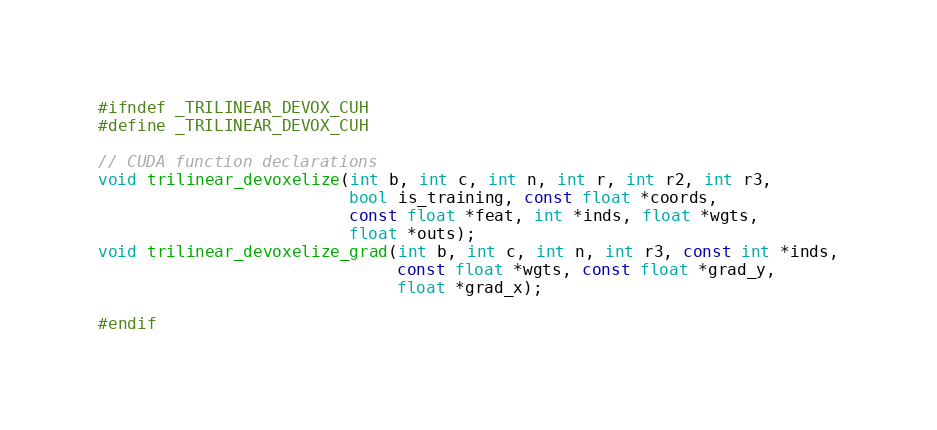<code> <loc_0><loc_0><loc_500><loc_500><_Cuda_>#ifndef _TRILINEAR_DEVOX_CUH
#define _TRILINEAR_DEVOX_CUH

// CUDA function declarations
void trilinear_devoxelize(int b, int c, int n, int r, int r2, int r3,
                          bool is_training, const float *coords,
                          const float *feat, int *inds, float *wgts,
                          float *outs);
void trilinear_devoxelize_grad(int b, int c, int n, int r3, const int *inds,
                               const float *wgts, const float *grad_y,
                               float *grad_x);

#endif
</code> 